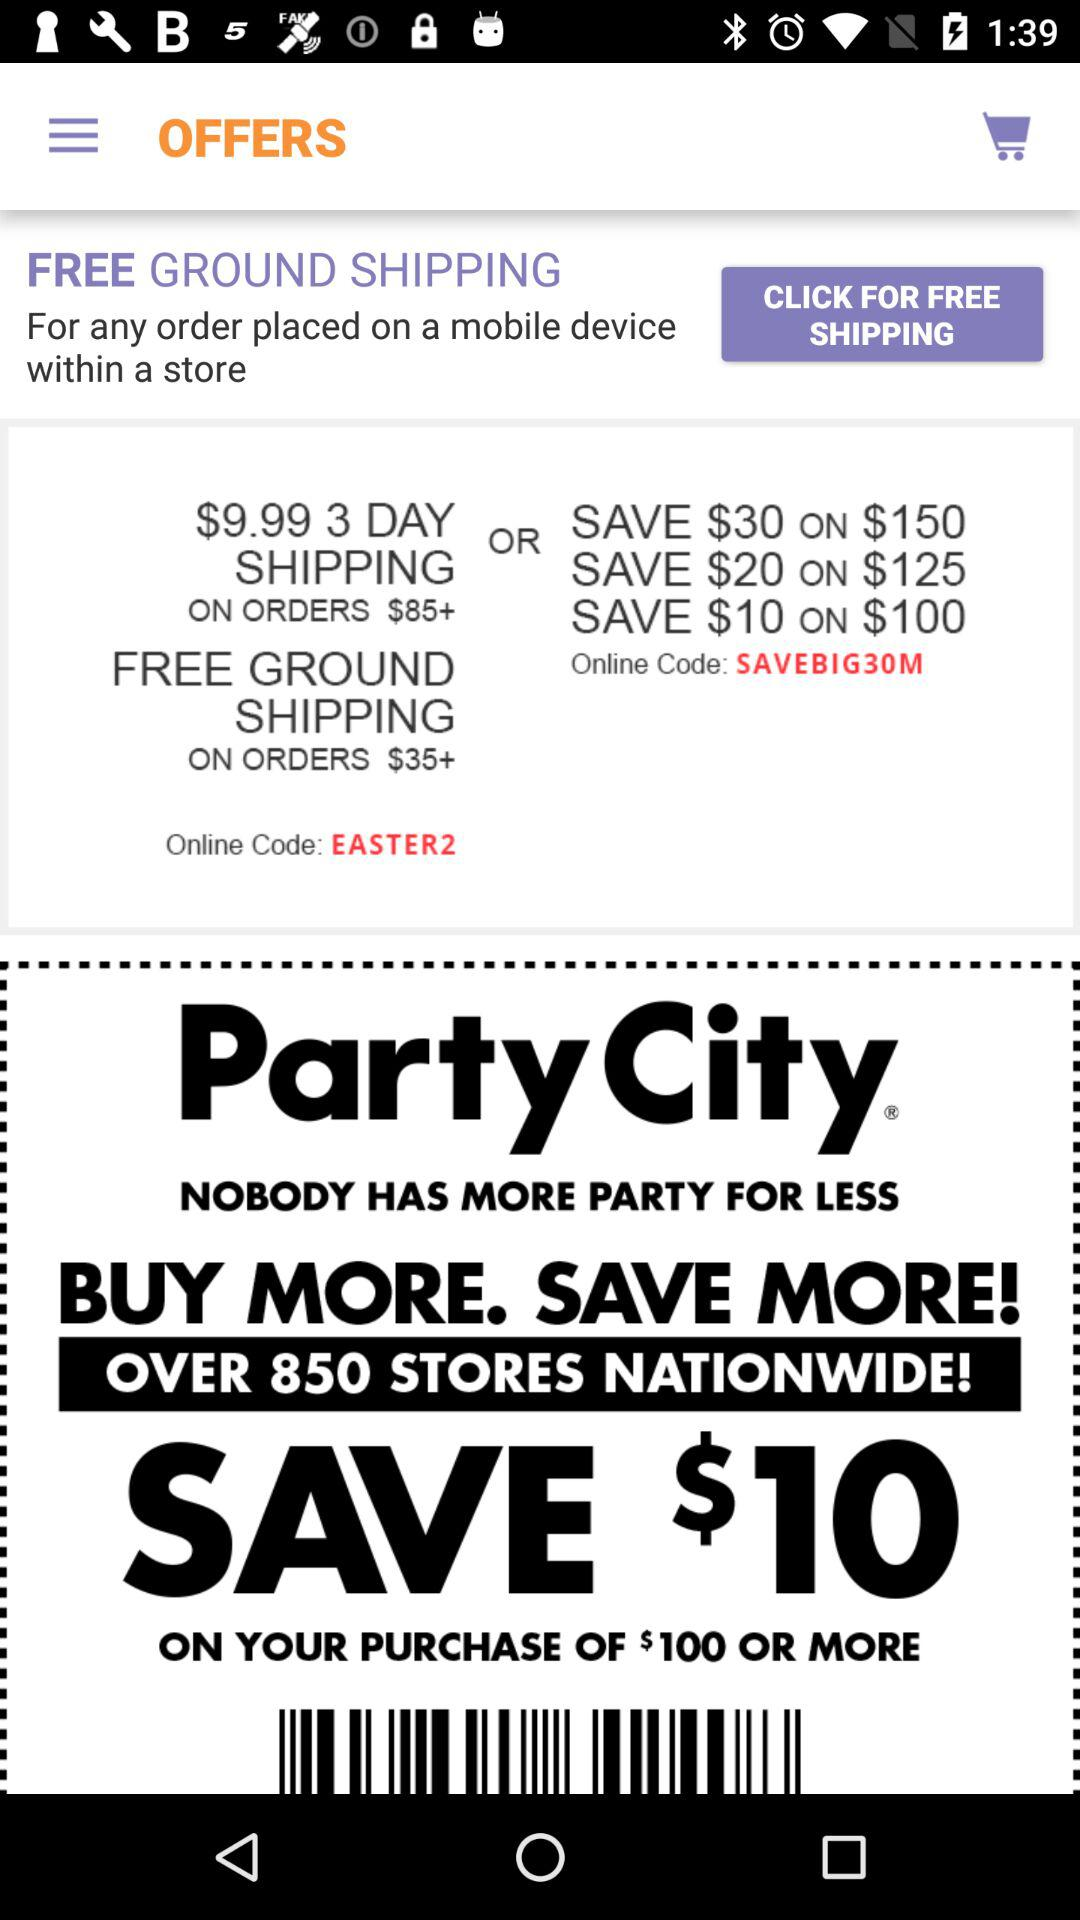On how much of the order's value can $30 be saved? $30 can be saved on the order's value of $150. 